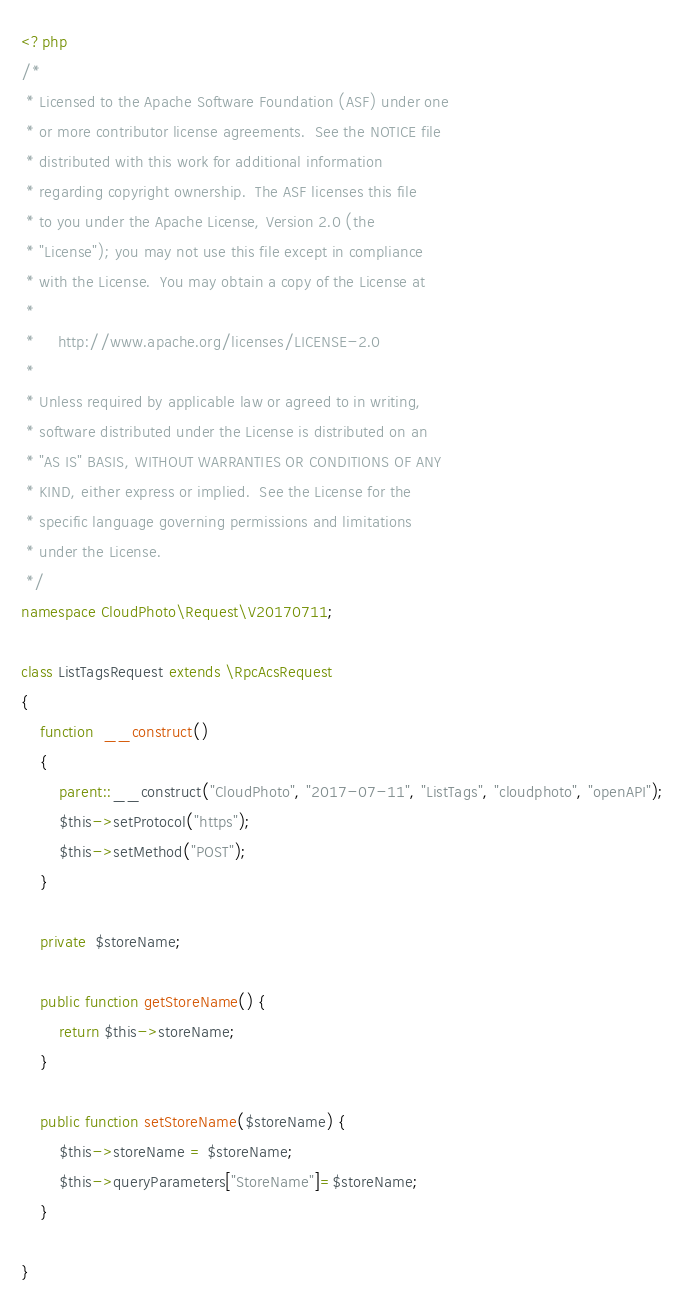Convert code to text. <code><loc_0><loc_0><loc_500><loc_500><_PHP_><?php
/*
 * Licensed to the Apache Software Foundation (ASF) under one
 * or more contributor license agreements.  See the NOTICE file
 * distributed with this work for additional information
 * regarding copyright ownership.  The ASF licenses this file
 * to you under the Apache License, Version 2.0 (the
 * "License"); you may not use this file except in compliance
 * with the License.  You may obtain a copy of the License at
 *
 *     http://www.apache.org/licenses/LICENSE-2.0
 *
 * Unless required by applicable law or agreed to in writing,
 * software distributed under the License is distributed on an
 * "AS IS" BASIS, WITHOUT WARRANTIES OR CONDITIONS OF ANY
 * KIND, either express or implied.  See the License for the
 * specific language governing permissions and limitations
 * under the License.
 */
namespace CloudPhoto\Request\V20170711;

class ListTagsRequest extends \RpcAcsRequest
{
	function  __construct()
	{
		parent::__construct("CloudPhoto", "2017-07-11", "ListTags", "cloudphoto", "openAPI");
		$this->setProtocol("https");
		$this->setMethod("POST");
	}

	private  $storeName;

	public function getStoreName() {
		return $this->storeName;
	}

	public function setStoreName($storeName) {
		$this->storeName = $storeName;
		$this->queryParameters["StoreName"]=$storeName;
	}
	
}</code> 